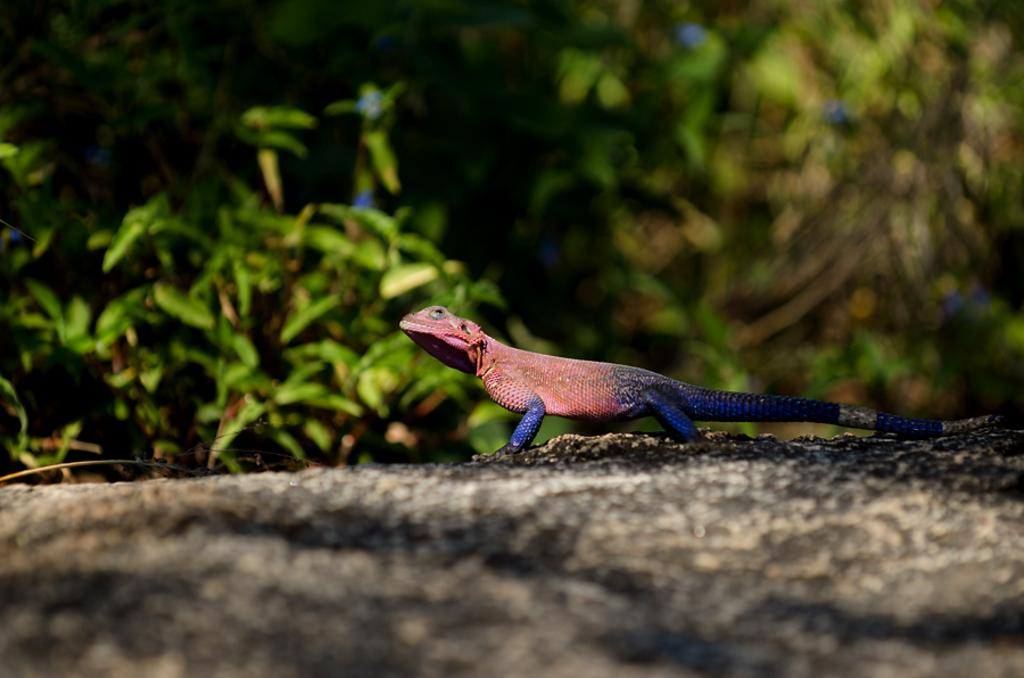What type of animal is on the surface in the image? There is a reptile on the surface in the image. What can be seen in the background of the image? The background of the image is green and blurred. What part of the reptile is covered in a cobweb in the image? There is no cobweb present in the image, and therefore no part of the reptile is covered by one. 